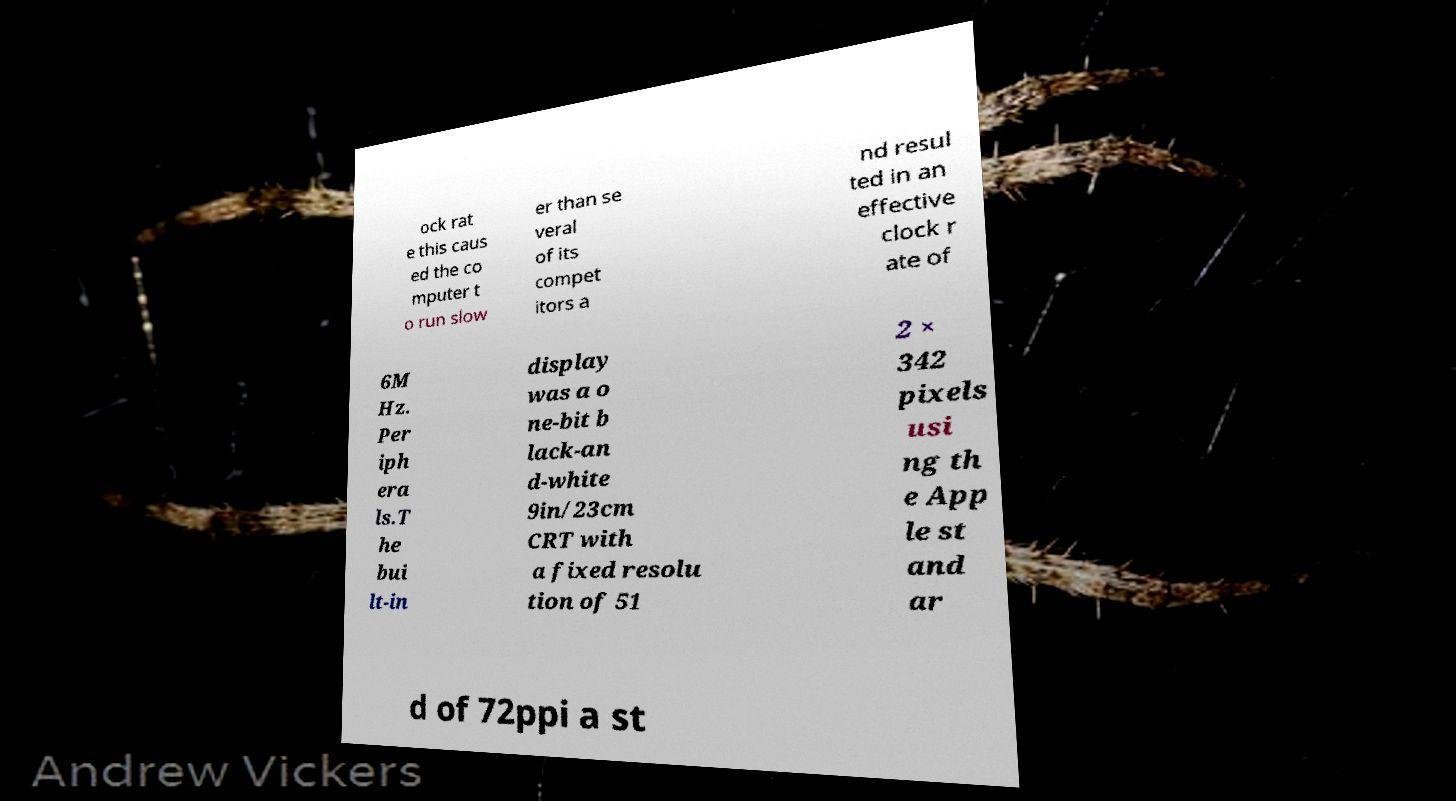Could you assist in decoding the text presented in this image and type it out clearly? ock rat e this caus ed the co mputer t o run slow er than se veral of its compet itors a nd resul ted in an effective clock r ate of 6M Hz. Per iph era ls.T he bui lt-in display was a o ne-bit b lack-an d-white 9in/23cm CRT with a fixed resolu tion of 51 2 × 342 pixels usi ng th e App le st and ar d of 72ppi a st 